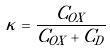Convert formula to latex. <formula><loc_0><loc_0><loc_500><loc_500>\kappa = \frac { C _ { O X } } { C _ { O X } + C _ { D } }</formula> 